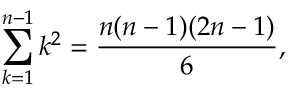Convert formula to latex. <formula><loc_0><loc_0><loc_500><loc_500>\sum _ { k = 1 } ^ { n - 1 } k ^ { 2 } = \frac { n ( n - 1 ) ( 2 n - 1 ) } { 6 } ,</formula> 